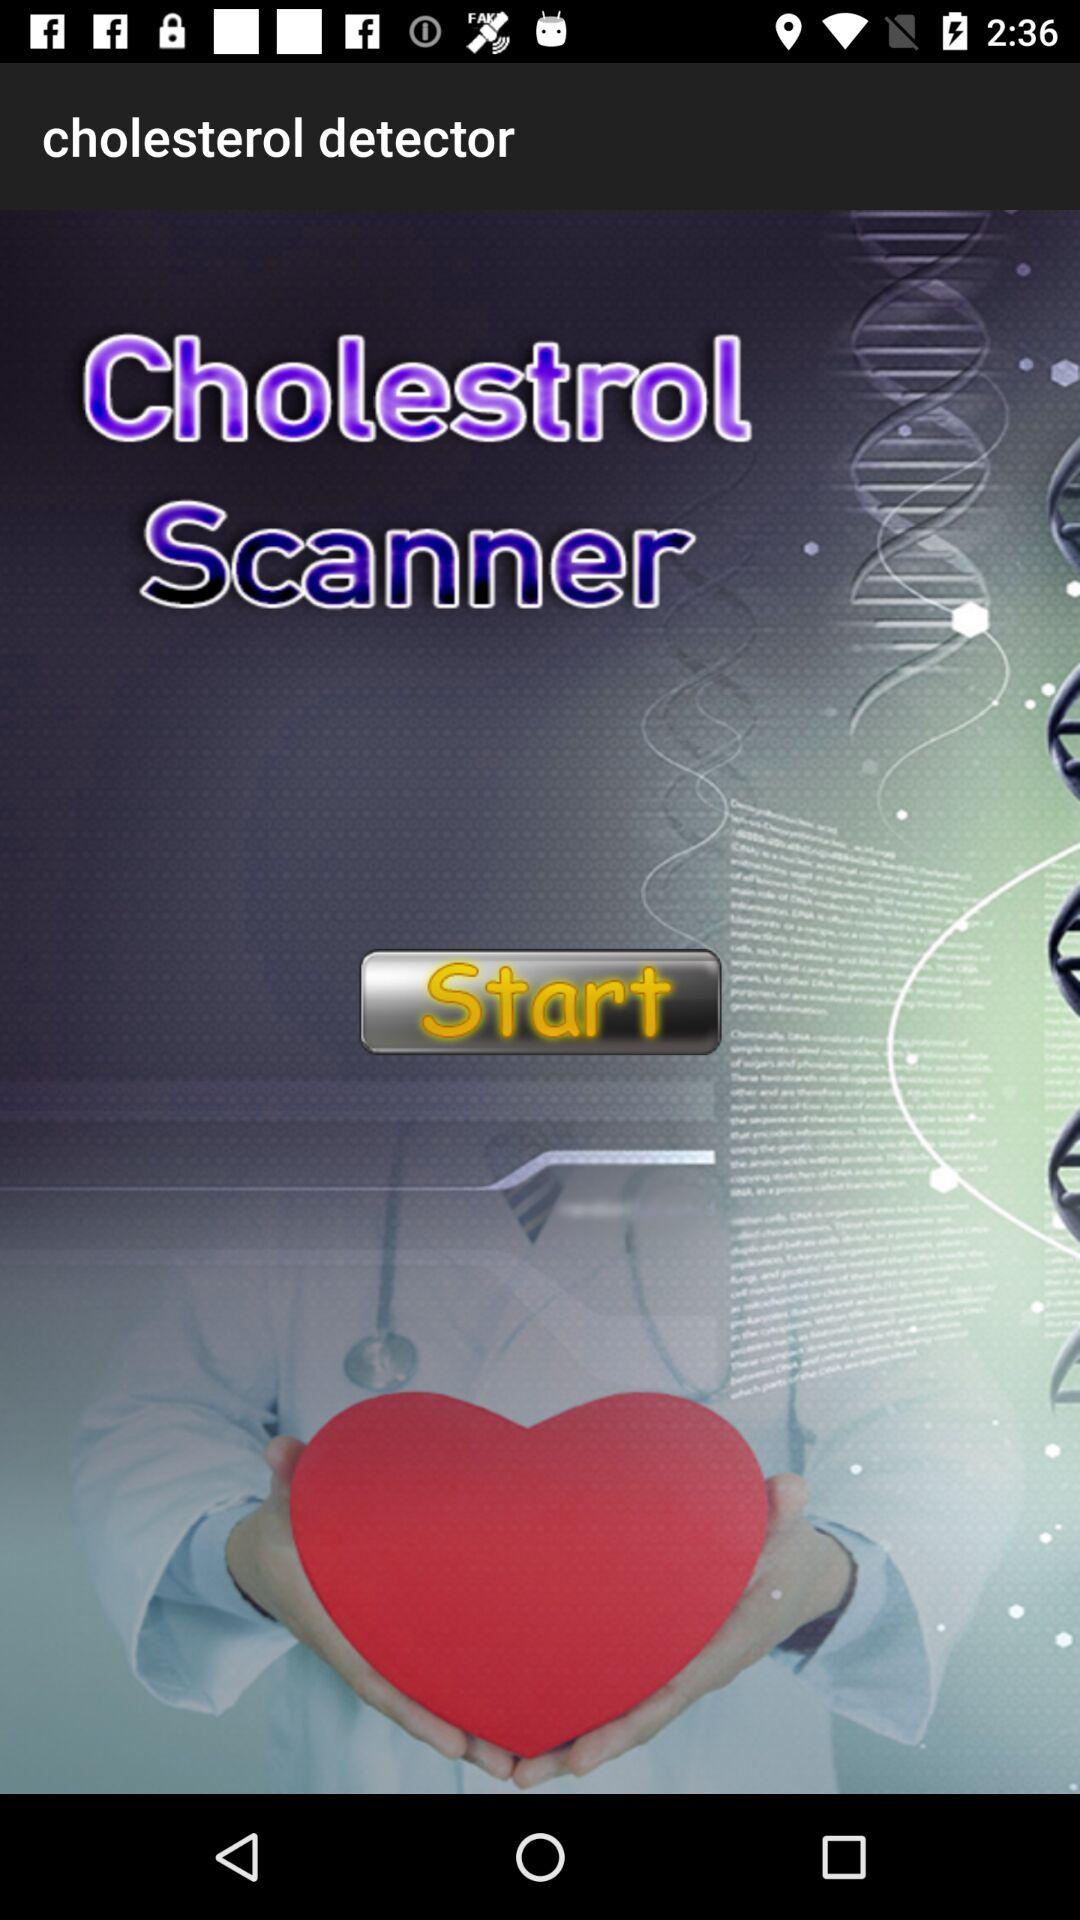What is the name of the application? The name of the application is "cholesterol detector". 